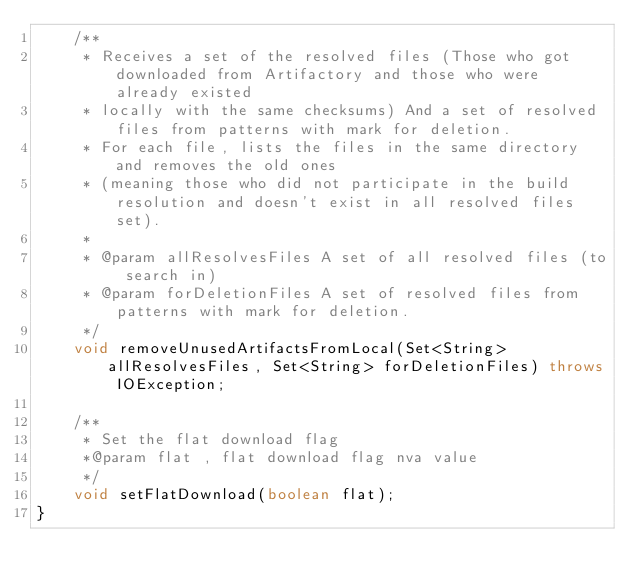Convert code to text. <code><loc_0><loc_0><loc_500><loc_500><_Java_>    /**
     * Receives a set of the resolved files (Those who got downloaded from Artifactory and those who were already existed
     * locally with the same checksums) And a set of resolved files from patterns with mark for deletion.
     * For each file, lists the files in the same directory and removes the old ones
     * (meaning those who did not participate in the build resolution and doesn't exist in all resolved files set).
     *
     * @param allResolvesFiles A set of all resolved files (to search in)
     * @param forDeletionFiles A set of resolved files from patterns with mark for deletion.
     */
    void removeUnusedArtifactsFromLocal(Set<String> allResolvesFiles, Set<String> forDeletionFiles) throws IOException;

    /**
     * Set the flat download flag
     *@param flat , flat download flag nva value
     */
    void setFlatDownload(boolean flat);
}
</code> 